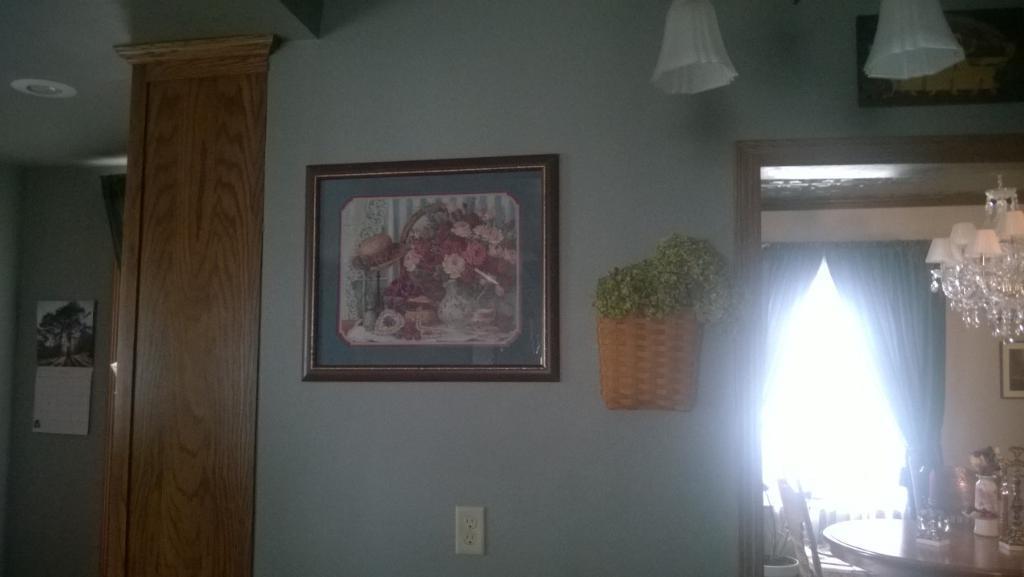Describe this image in one or two sentences. In this image on the wall there are frames, stand, poster are there. This is an entrance. In the bottom right there is a table and chair. On the table there are bottles, glasses, few other things. These are curtains. On the top there is a chandelier. There are lights on the top. 